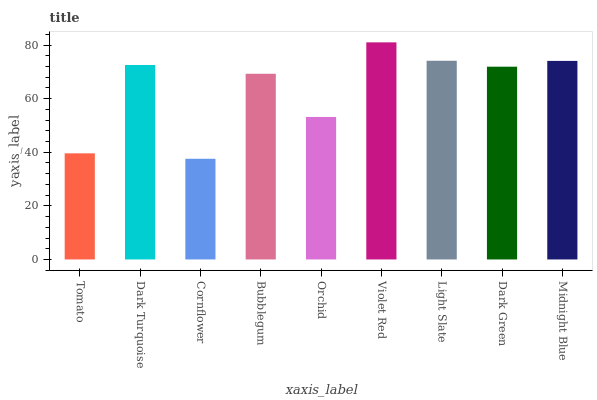Is Dark Turquoise the minimum?
Answer yes or no. No. Is Dark Turquoise the maximum?
Answer yes or no. No. Is Dark Turquoise greater than Tomato?
Answer yes or no. Yes. Is Tomato less than Dark Turquoise?
Answer yes or no. Yes. Is Tomato greater than Dark Turquoise?
Answer yes or no. No. Is Dark Turquoise less than Tomato?
Answer yes or no. No. Is Dark Green the high median?
Answer yes or no. Yes. Is Dark Green the low median?
Answer yes or no. Yes. Is Cornflower the high median?
Answer yes or no. No. Is Light Slate the low median?
Answer yes or no. No. 